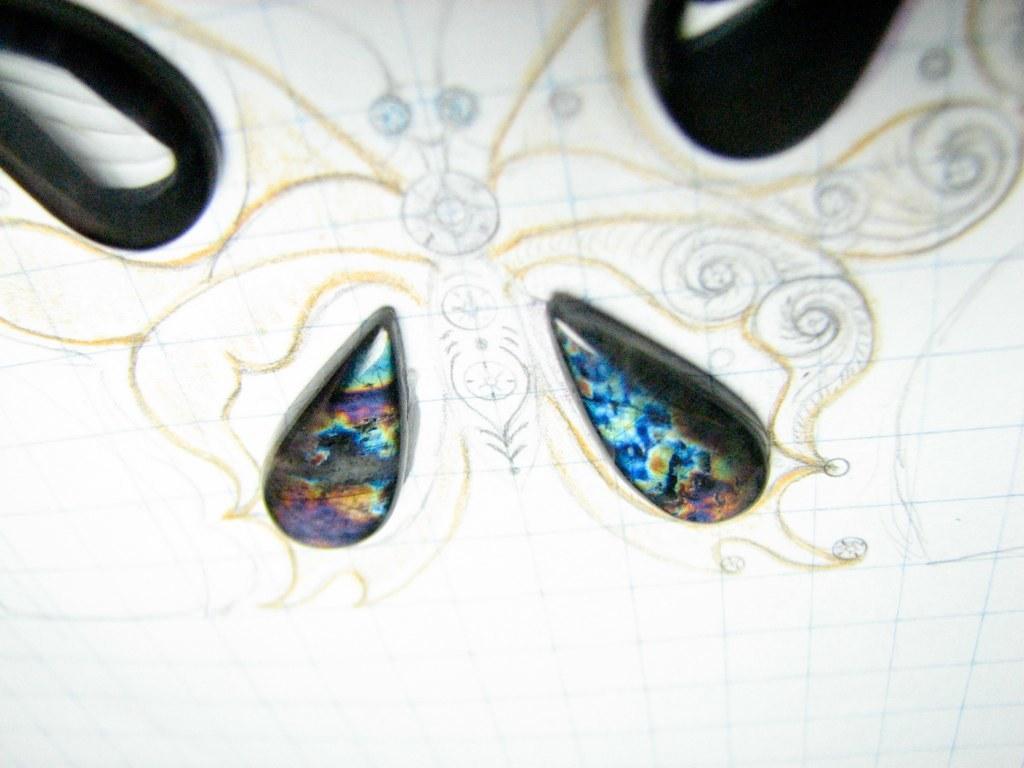Please provide a concise description of this image. Here I can see a drawing and few stones on a white paper. 